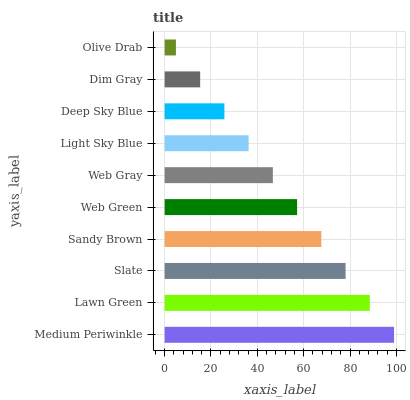Is Olive Drab the minimum?
Answer yes or no. Yes. Is Medium Periwinkle the maximum?
Answer yes or no. Yes. Is Lawn Green the minimum?
Answer yes or no. No. Is Lawn Green the maximum?
Answer yes or no. No. Is Medium Periwinkle greater than Lawn Green?
Answer yes or no. Yes. Is Lawn Green less than Medium Periwinkle?
Answer yes or no. Yes. Is Lawn Green greater than Medium Periwinkle?
Answer yes or no. No. Is Medium Periwinkle less than Lawn Green?
Answer yes or no. No. Is Web Green the high median?
Answer yes or no. Yes. Is Web Gray the low median?
Answer yes or no. Yes. Is Dim Gray the high median?
Answer yes or no. No. Is Web Green the low median?
Answer yes or no. No. 